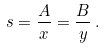<formula> <loc_0><loc_0><loc_500><loc_500>s = \frac { A } { x } = \frac { B } { y } \, .</formula> 